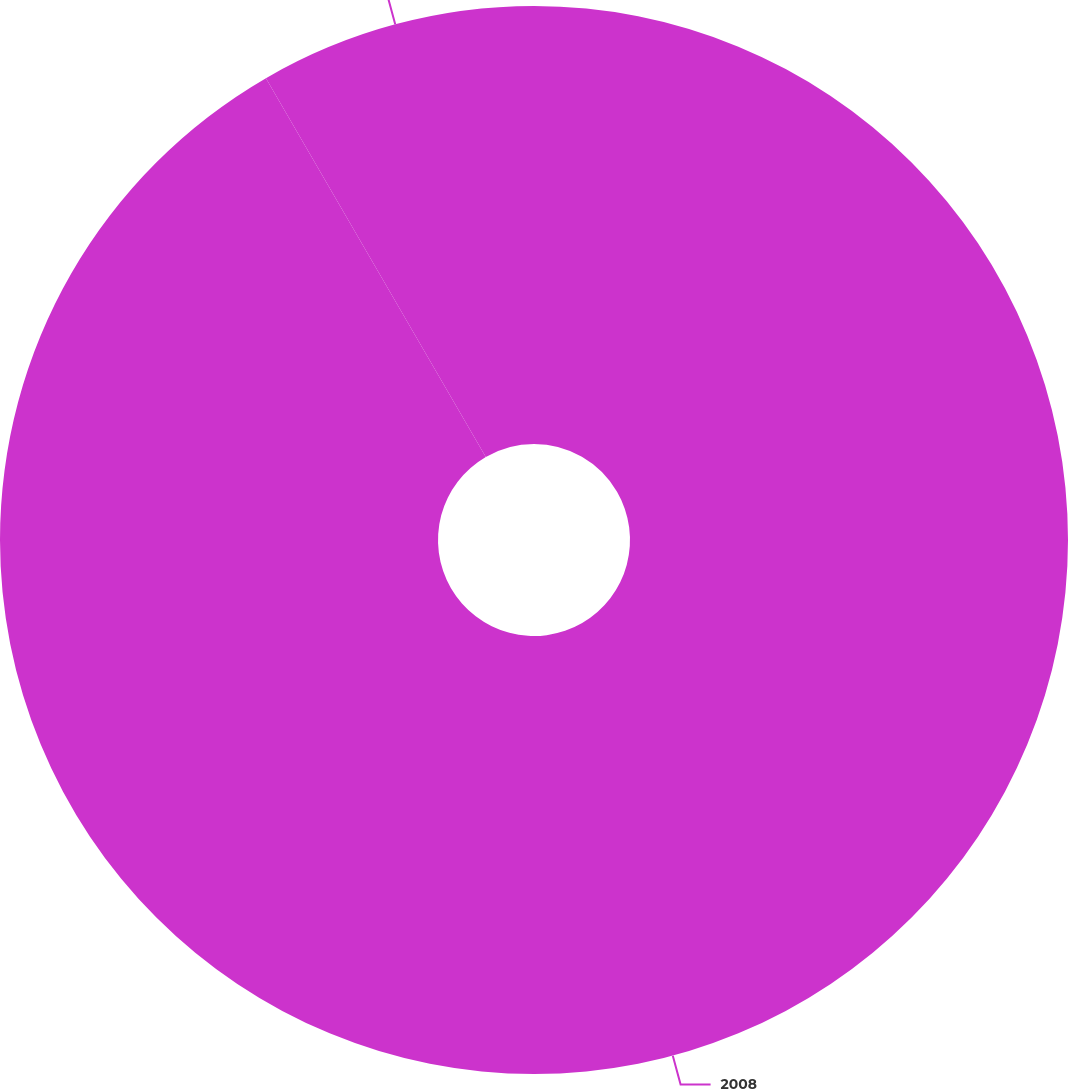<chart> <loc_0><loc_0><loc_500><loc_500><pie_chart><fcel>2008<fcel>10000<nl><fcel>91.63%<fcel>8.37%<nl></chart> 